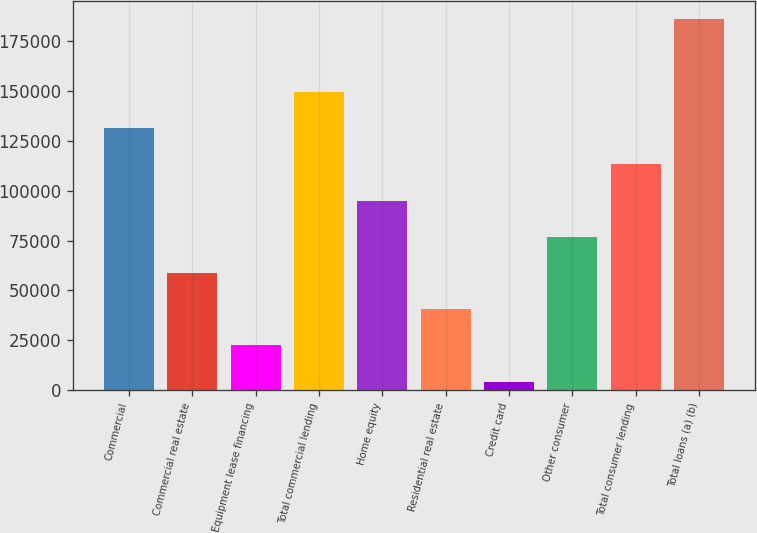<chart> <loc_0><loc_0><loc_500><loc_500><bar_chart><fcel>Commercial<fcel>Commercial real estate<fcel>Equipment lease financing<fcel>Total commercial lending<fcel>Home equity<fcel>Residential real estate<fcel>Credit card<fcel>Other consumer<fcel>Total consumer lending<fcel>Total loans (a) (b)<nl><fcel>131390<fcel>58768.9<fcel>22458.3<fcel>149545<fcel>95079.5<fcel>40613.6<fcel>4303<fcel>76924.2<fcel>113235<fcel>185856<nl></chart> 